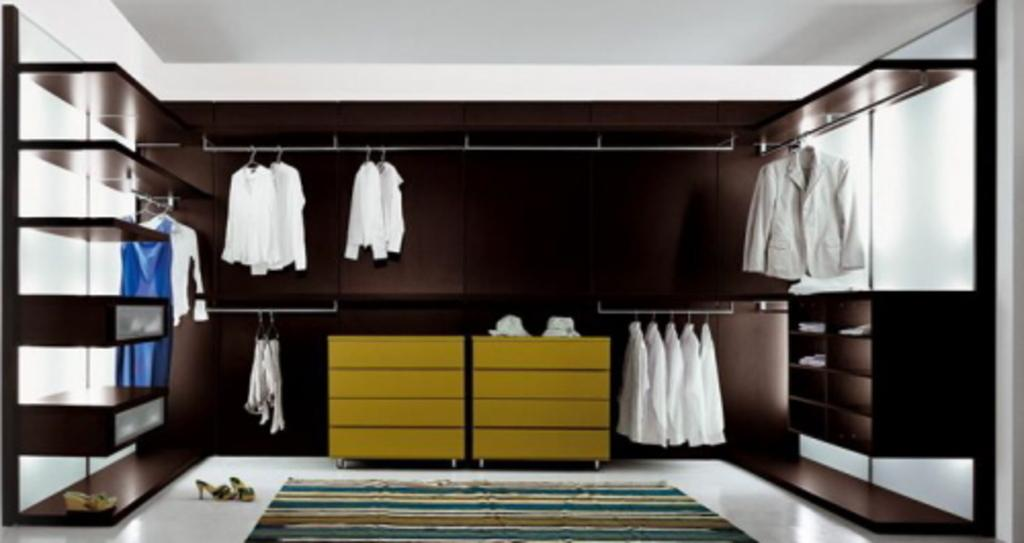What is the method used to store the clothes in the image? The clothes are arranged in a cupboard in the image. How are the clothes hung in the cupboard? The clothes are hung using hangers in the image. What type of footwear is placed on the floor in the image? There are sandals placed on the floor in the image. What type of cord is used to organize the knowledge in the image? There is no mention of a cord or knowledge in the image; it features clothes arranged in a cupboard and sandals on the floor. 